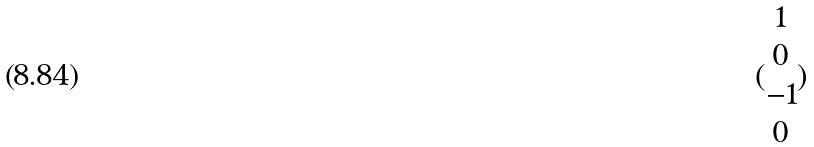<formula> <loc_0><loc_0><loc_500><loc_500>( \begin{matrix} 1 \\ 0 \\ - 1 \\ 0 \end{matrix} )</formula> 